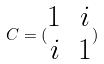<formula> <loc_0><loc_0><loc_500><loc_500>C = ( \begin{matrix} 1 & i \\ i & 1 \end{matrix} )</formula> 